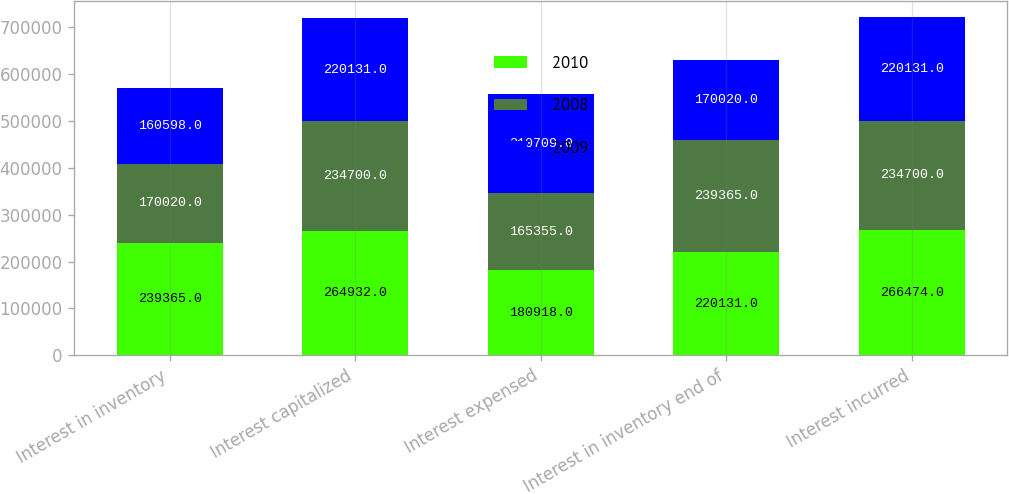Convert chart to OTSL. <chart><loc_0><loc_0><loc_500><loc_500><stacked_bar_chart><ecel><fcel>Interest in inventory<fcel>Interest capitalized<fcel>Interest expensed<fcel>Interest in inventory end of<fcel>Interest incurred<nl><fcel>2010<fcel>239365<fcel>264932<fcel>180918<fcel>220131<fcel>266474<nl><fcel>2008<fcel>170020<fcel>234700<fcel>165355<fcel>239365<fcel>234700<nl><fcel>2009<fcel>160598<fcel>220131<fcel>210709<fcel>170020<fcel>220131<nl></chart> 